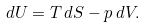Convert formula to latex. <formula><loc_0><loc_0><loc_500><loc_500>d U = T \, d S - p \, d V .</formula> 